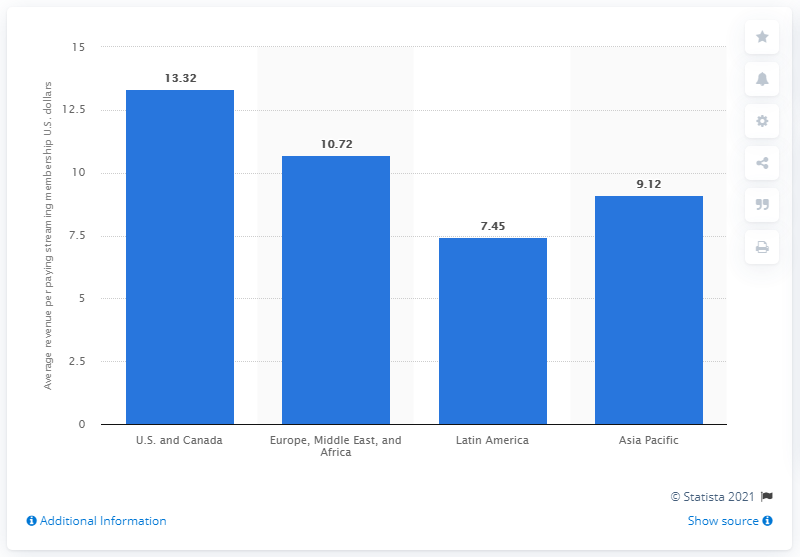Indicate a few pertinent items in this graphic. In 2020, Netflix generated an average of 13.32 US dollars in revenue for each paying customer in North America. 